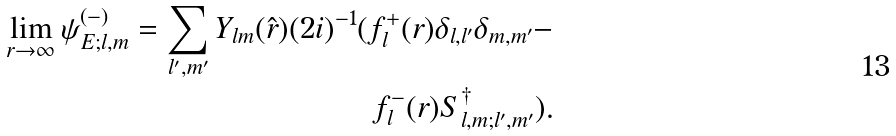<formula> <loc_0><loc_0><loc_500><loc_500>\lim _ { r \to \infty } \psi ^ { ( - ) } _ { E ; l , m } = \sum _ { l ^ { \prime } , m ^ { \prime } } Y _ { l m } ( \hat { r } ) ( 2 i ) ^ { - 1 } ( f _ { l } ^ { + } ( r ) \delta _ { l , l ^ { \prime } } \delta _ { m , m ^ { \prime } } - \\ f _ { l } ^ { - } ( r ) S ^ { \dag } _ { l , m ; l ^ { \prime } , m ^ { \prime } } ) .</formula> 